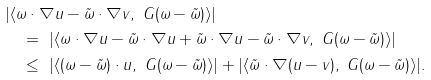<formula> <loc_0><loc_0><loc_500><loc_500>& | \langle \omega \cdot \nabla u - \tilde { \omega } \cdot \nabla v , \ G ( \omega - \tilde { \omega } ) \rangle | \\ & \quad = \ | \langle \omega \cdot \nabla u - \tilde { \omega } \cdot \nabla u + \tilde { \omega } \cdot \nabla u - \tilde { \omega } \cdot \nabla v , \ G ( \omega - \tilde { \omega } ) \rangle | \\ & \quad \leq \ | \langle ( \omega - \tilde { \omega } ) \cdot u , \ G ( \omega - \tilde { \omega } ) \rangle | + | \langle \tilde { \omega } \cdot \nabla ( u - v ) , \ G ( \omega - \tilde { \omega } ) \rangle | .</formula> 